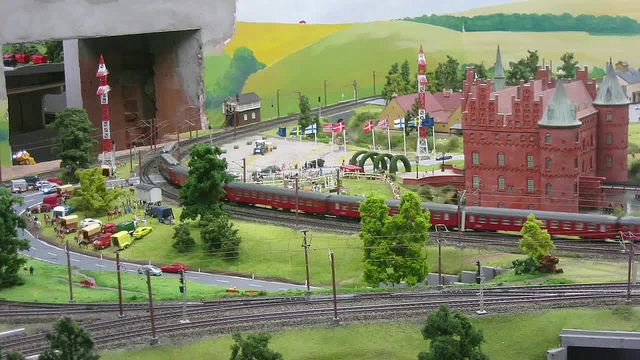What types of vehicles can be seen in the image besides the train? Besides the train, the image also shows several cars of different models, a few buses, and trucks. These vehicles are all part of the miniature setting, adding to the lively and realistic nature of the scene. 